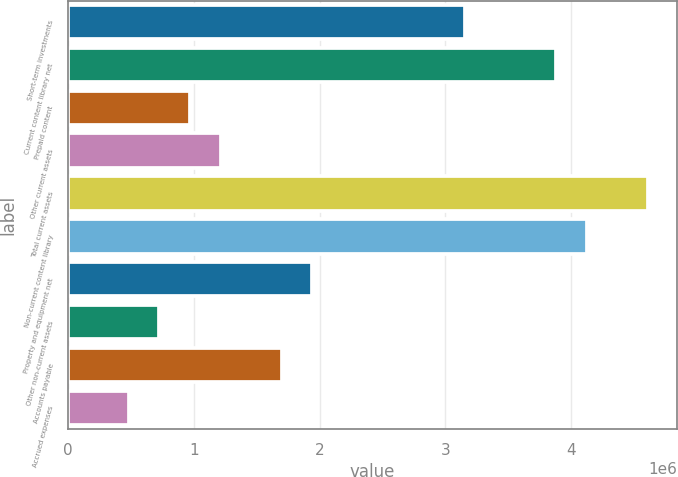Convert chart to OTSL. <chart><loc_0><loc_0><loc_500><loc_500><bar_chart><fcel>Short-term investments<fcel>Current content library net<fcel>Prepaid content<fcel>Other current assets<fcel>Total current assets<fcel>Non-current content library<fcel>Property and equipment net<fcel>Other non-current assets<fcel>Accounts payable<fcel>Accrued expenses<nl><fcel>3.15429e+06<fcel>3.88218e+06<fcel>970587<fcel>1.21322e+06<fcel>4.61008e+06<fcel>4.12482e+06<fcel>1.94112e+06<fcel>727954<fcel>1.69849e+06<fcel>485321<nl></chart> 